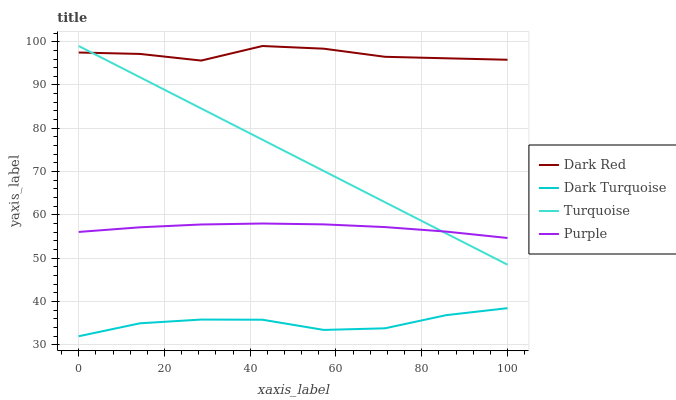Does Dark Turquoise have the minimum area under the curve?
Answer yes or no. Yes. Does Dark Red have the maximum area under the curve?
Answer yes or no. Yes. Does Turquoise have the minimum area under the curve?
Answer yes or no. No. Does Turquoise have the maximum area under the curve?
Answer yes or no. No. Is Turquoise the smoothest?
Answer yes or no. Yes. Is Dark Red the roughest?
Answer yes or no. Yes. Is Dark Red the smoothest?
Answer yes or no. No. Is Turquoise the roughest?
Answer yes or no. No. Does Dark Turquoise have the lowest value?
Answer yes or no. Yes. Does Turquoise have the lowest value?
Answer yes or no. No. Does Turquoise have the highest value?
Answer yes or no. Yes. Does Dark Turquoise have the highest value?
Answer yes or no. No. Is Dark Turquoise less than Dark Red?
Answer yes or no. Yes. Is Purple greater than Dark Turquoise?
Answer yes or no. Yes. Does Turquoise intersect Dark Red?
Answer yes or no. Yes. Is Turquoise less than Dark Red?
Answer yes or no. No. Is Turquoise greater than Dark Red?
Answer yes or no. No. Does Dark Turquoise intersect Dark Red?
Answer yes or no. No. 